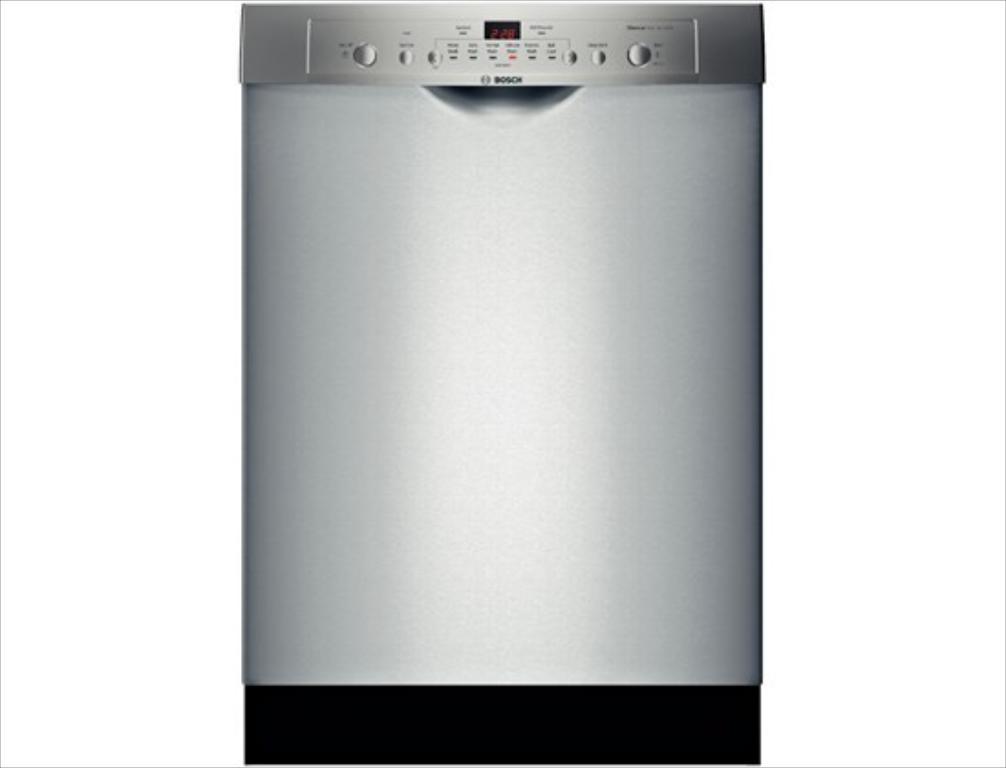How would you summarize this image in a sentence or two? In the center of the image, we can see a dishwasher and at the top, we can see some text on it. 